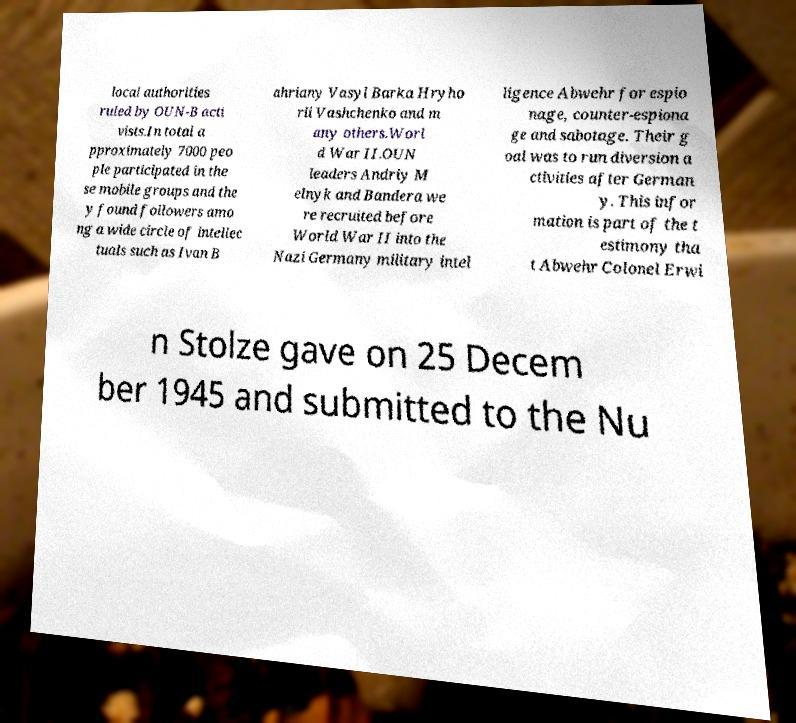I need the written content from this picture converted into text. Can you do that? local authorities ruled by OUN-B acti vists.In total a pproximately 7000 peo ple participated in the se mobile groups and the y found followers amo ng a wide circle of intellec tuals such as Ivan B ahriany Vasyl Barka Hryho rii Vashchenko and m any others.Worl d War II.OUN leaders Andriy M elnyk and Bandera we re recruited before World War II into the Nazi Germany military intel ligence Abwehr for espio nage, counter-espiona ge and sabotage. Their g oal was to run diversion a ctivities after German y. This infor mation is part of the t estimony tha t Abwehr Colonel Erwi n Stolze gave on 25 Decem ber 1945 and submitted to the Nu 